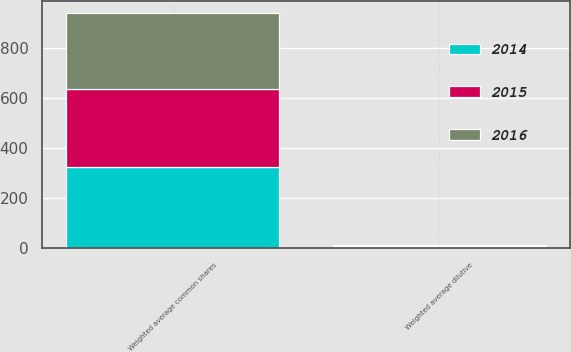<chart> <loc_0><loc_0><loc_500><loc_500><stacked_bar_chart><ecel><fcel>Weighted average common shares<fcel>Weighted average dilutive<nl><fcel>2016<fcel>303.1<fcel>3.8<nl><fcel>2015<fcel>314.7<fcel>4.4<nl><fcel>2014<fcel>322.4<fcel>5.6<nl></chart> 